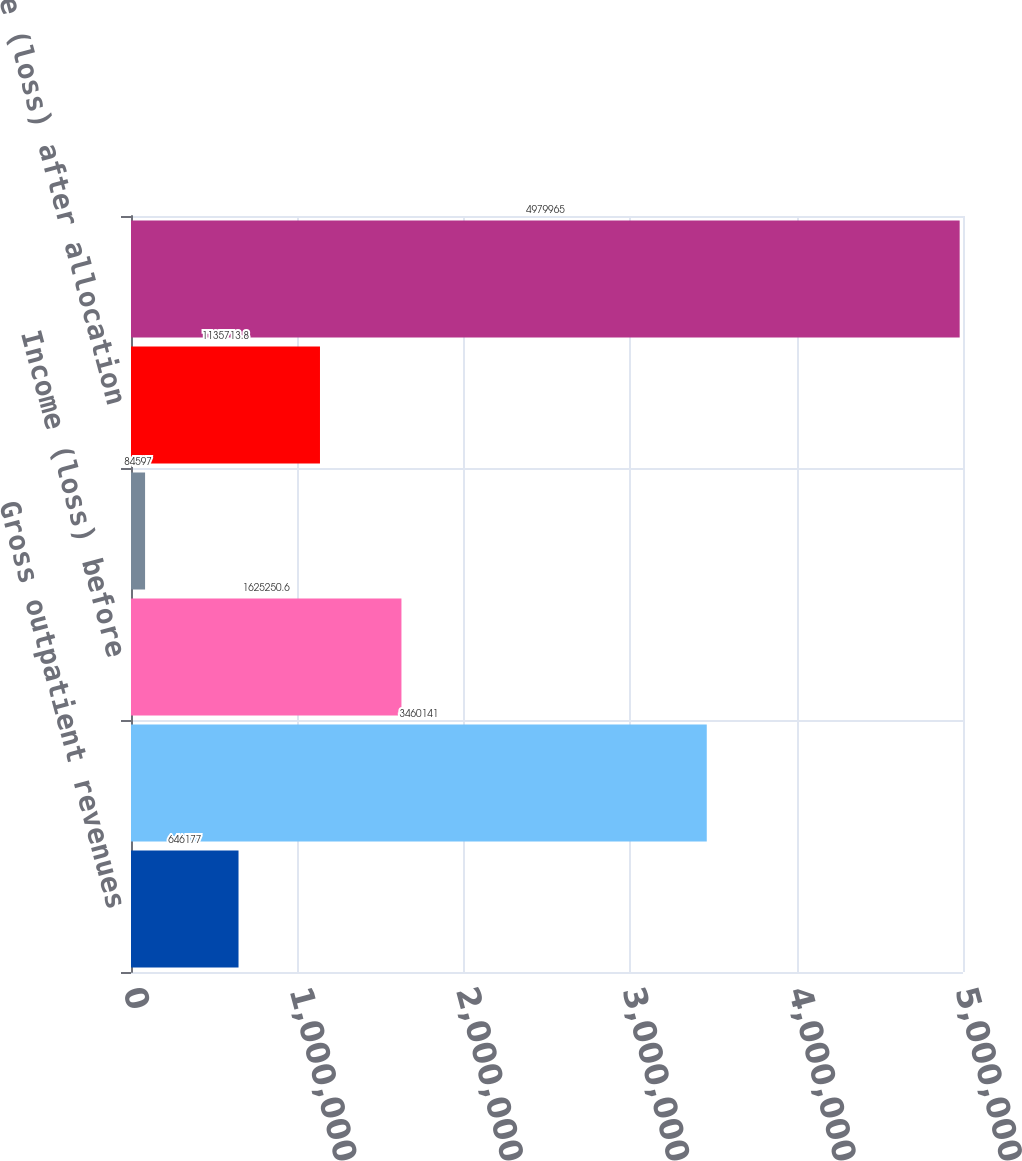Convert chart. <chart><loc_0><loc_0><loc_500><loc_500><bar_chart><fcel>Gross outpatient revenues<fcel>Total net revenues<fcel>Income (loss) before<fcel>Allocation of corporate<fcel>Income (loss) after allocation<fcel>Total assets<nl><fcel>646177<fcel>3.46014e+06<fcel>1.62525e+06<fcel>84597<fcel>1.13571e+06<fcel>4.97996e+06<nl></chart> 